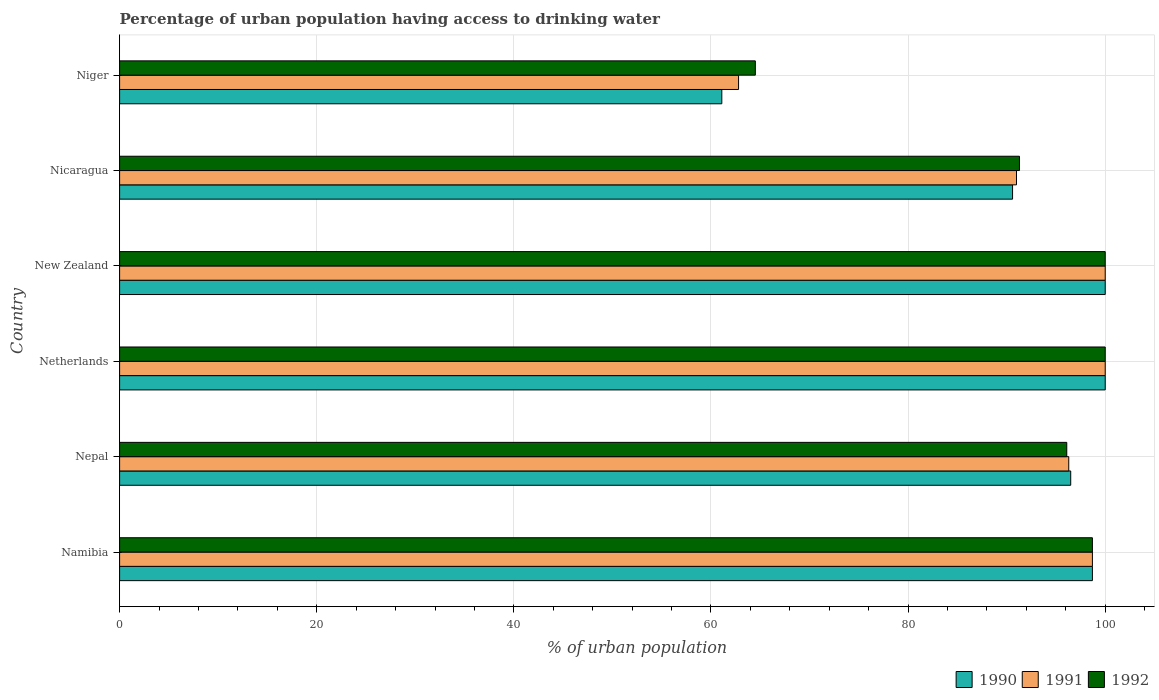How many different coloured bars are there?
Offer a very short reply. 3. Are the number of bars on each tick of the Y-axis equal?
Offer a terse response. Yes. What is the label of the 3rd group of bars from the top?
Give a very brief answer. New Zealand. What is the percentage of urban population having access to drinking water in 1990 in Nepal?
Provide a short and direct response. 96.5. Across all countries, what is the maximum percentage of urban population having access to drinking water in 1991?
Keep it short and to the point. 100. Across all countries, what is the minimum percentage of urban population having access to drinking water in 1991?
Provide a succinct answer. 62.8. In which country was the percentage of urban population having access to drinking water in 1992 maximum?
Make the answer very short. Netherlands. In which country was the percentage of urban population having access to drinking water in 1990 minimum?
Make the answer very short. Niger. What is the total percentage of urban population having access to drinking water in 1991 in the graph?
Give a very brief answer. 548.8. What is the difference between the percentage of urban population having access to drinking water in 1992 in Netherlands and that in Niger?
Your answer should be compact. 35.5. What is the difference between the percentage of urban population having access to drinking water in 1992 in Namibia and the percentage of urban population having access to drinking water in 1990 in Niger?
Keep it short and to the point. 37.6. What is the average percentage of urban population having access to drinking water in 1992 per country?
Give a very brief answer. 91.77. In how many countries, is the percentage of urban population having access to drinking water in 1992 greater than 44 %?
Give a very brief answer. 6. What is the ratio of the percentage of urban population having access to drinking water in 1992 in New Zealand to that in Niger?
Make the answer very short. 1.55. Is the percentage of urban population having access to drinking water in 1990 in Namibia less than that in Niger?
Keep it short and to the point. No. What is the difference between the highest and the second highest percentage of urban population having access to drinking water in 1992?
Provide a succinct answer. 0. What is the difference between the highest and the lowest percentage of urban population having access to drinking water in 1992?
Keep it short and to the point. 35.5. Are all the bars in the graph horizontal?
Your response must be concise. Yes. Are the values on the major ticks of X-axis written in scientific E-notation?
Provide a succinct answer. No. Does the graph contain grids?
Give a very brief answer. Yes. Where does the legend appear in the graph?
Give a very brief answer. Bottom right. How are the legend labels stacked?
Your answer should be very brief. Horizontal. What is the title of the graph?
Your response must be concise. Percentage of urban population having access to drinking water. What is the label or title of the X-axis?
Give a very brief answer. % of urban population. What is the % of urban population of 1990 in Namibia?
Make the answer very short. 98.7. What is the % of urban population in 1991 in Namibia?
Ensure brevity in your answer.  98.7. What is the % of urban population in 1992 in Namibia?
Provide a short and direct response. 98.7. What is the % of urban population of 1990 in Nepal?
Keep it short and to the point. 96.5. What is the % of urban population in 1991 in Nepal?
Your answer should be very brief. 96.3. What is the % of urban population in 1992 in Nepal?
Keep it short and to the point. 96.1. What is the % of urban population in 1991 in Netherlands?
Make the answer very short. 100. What is the % of urban population of 1992 in Netherlands?
Provide a short and direct response. 100. What is the % of urban population of 1990 in New Zealand?
Your answer should be very brief. 100. What is the % of urban population of 1991 in New Zealand?
Offer a terse response. 100. What is the % of urban population of 1990 in Nicaragua?
Provide a short and direct response. 90.6. What is the % of urban population of 1991 in Nicaragua?
Offer a terse response. 91. What is the % of urban population of 1992 in Nicaragua?
Your answer should be compact. 91.3. What is the % of urban population of 1990 in Niger?
Your answer should be very brief. 61.1. What is the % of urban population in 1991 in Niger?
Provide a short and direct response. 62.8. What is the % of urban population in 1992 in Niger?
Ensure brevity in your answer.  64.5. Across all countries, what is the maximum % of urban population in 1990?
Your answer should be very brief. 100. Across all countries, what is the maximum % of urban population of 1991?
Offer a terse response. 100. Across all countries, what is the maximum % of urban population in 1992?
Make the answer very short. 100. Across all countries, what is the minimum % of urban population of 1990?
Your response must be concise. 61.1. Across all countries, what is the minimum % of urban population of 1991?
Provide a succinct answer. 62.8. Across all countries, what is the minimum % of urban population in 1992?
Ensure brevity in your answer.  64.5. What is the total % of urban population of 1990 in the graph?
Keep it short and to the point. 546.9. What is the total % of urban population in 1991 in the graph?
Provide a short and direct response. 548.8. What is the total % of urban population of 1992 in the graph?
Provide a short and direct response. 550.6. What is the difference between the % of urban population of 1992 in Namibia and that in Nepal?
Provide a succinct answer. 2.6. What is the difference between the % of urban population of 1992 in Namibia and that in Netherlands?
Your response must be concise. -1.3. What is the difference between the % of urban population in 1991 in Namibia and that in New Zealand?
Make the answer very short. -1.3. What is the difference between the % of urban population of 1990 in Namibia and that in Niger?
Ensure brevity in your answer.  37.6. What is the difference between the % of urban population in 1991 in Namibia and that in Niger?
Your answer should be very brief. 35.9. What is the difference between the % of urban population in 1992 in Namibia and that in Niger?
Provide a short and direct response. 34.2. What is the difference between the % of urban population of 1992 in Nepal and that in Netherlands?
Make the answer very short. -3.9. What is the difference between the % of urban population in 1991 in Nepal and that in New Zealand?
Provide a succinct answer. -3.7. What is the difference between the % of urban population of 1991 in Nepal and that in Nicaragua?
Offer a terse response. 5.3. What is the difference between the % of urban population in 1990 in Nepal and that in Niger?
Your response must be concise. 35.4. What is the difference between the % of urban population of 1991 in Nepal and that in Niger?
Ensure brevity in your answer.  33.5. What is the difference between the % of urban population of 1992 in Nepal and that in Niger?
Your response must be concise. 31.6. What is the difference between the % of urban population of 1991 in Netherlands and that in New Zealand?
Offer a very short reply. 0. What is the difference between the % of urban population in 1990 in Netherlands and that in Nicaragua?
Provide a short and direct response. 9.4. What is the difference between the % of urban population in 1990 in Netherlands and that in Niger?
Offer a terse response. 38.9. What is the difference between the % of urban population of 1991 in Netherlands and that in Niger?
Make the answer very short. 37.2. What is the difference between the % of urban population in 1992 in Netherlands and that in Niger?
Offer a terse response. 35.5. What is the difference between the % of urban population of 1990 in New Zealand and that in Niger?
Ensure brevity in your answer.  38.9. What is the difference between the % of urban population of 1991 in New Zealand and that in Niger?
Your response must be concise. 37.2. What is the difference between the % of urban population of 1992 in New Zealand and that in Niger?
Ensure brevity in your answer.  35.5. What is the difference between the % of urban population in 1990 in Nicaragua and that in Niger?
Make the answer very short. 29.5. What is the difference between the % of urban population in 1991 in Nicaragua and that in Niger?
Provide a succinct answer. 28.2. What is the difference between the % of urban population of 1992 in Nicaragua and that in Niger?
Your answer should be compact. 26.8. What is the difference between the % of urban population of 1990 in Namibia and the % of urban population of 1992 in Nepal?
Provide a succinct answer. 2.6. What is the difference between the % of urban population of 1991 in Namibia and the % of urban population of 1992 in Netherlands?
Your answer should be compact. -1.3. What is the difference between the % of urban population of 1990 in Namibia and the % of urban population of 1991 in New Zealand?
Make the answer very short. -1.3. What is the difference between the % of urban population of 1990 in Namibia and the % of urban population of 1992 in New Zealand?
Offer a very short reply. -1.3. What is the difference between the % of urban population of 1991 in Namibia and the % of urban population of 1992 in New Zealand?
Offer a very short reply. -1.3. What is the difference between the % of urban population in 1991 in Namibia and the % of urban population in 1992 in Nicaragua?
Offer a very short reply. 7.4. What is the difference between the % of urban population of 1990 in Namibia and the % of urban population of 1991 in Niger?
Your response must be concise. 35.9. What is the difference between the % of urban population in 1990 in Namibia and the % of urban population in 1992 in Niger?
Your response must be concise. 34.2. What is the difference between the % of urban population of 1991 in Namibia and the % of urban population of 1992 in Niger?
Provide a succinct answer. 34.2. What is the difference between the % of urban population of 1990 in Nepal and the % of urban population of 1991 in Netherlands?
Provide a short and direct response. -3.5. What is the difference between the % of urban population in 1990 in Nepal and the % of urban population in 1992 in Netherlands?
Your response must be concise. -3.5. What is the difference between the % of urban population of 1991 in Nepal and the % of urban population of 1992 in Netherlands?
Provide a short and direct response. -3.7. What is the difference between the % of urban population of 1991 in Nepal and the % of urban population of 1992 in New Zealand?
Keep it short and to the point. -3.7. What is the difference between the % of urban population of 1990 in Nepal and the % of urban population of 1991 in Nicaragua?
Give a very brief answer. 5.5. What is the difference between the % of urban population of 1991 in Nepal and the % of urban population of 1992 in Nicaragua?
Offer a terse response. 5. What is the difference between the % of urban population in 1990 in Nepal and the % of urban population in 1991 in Niger?
Offer a terse response. 33.7. What is the difference between the % of urban population of 1990 in Nepal and the % of urban population of 1992 in Niger?
Make the answer very short. 32. What is the difference between the % of urban population in 1991 in Nepal and the % of urban population in 1992 in Niger?
Ensure brevity in your answer.  31.8. What is the difference between the % of urban population in 1991 in Netherlands and the % of urban population in 1992 in New Zealand?
Ensure brevity in your answer.  0. What is the difference between the % of urban population in 1991 in Netherlands and the % of urban population in 1992 in Nicaragua?
Your answer should be very brief. 8.7. What is the difference between the % of urban population in 1990 in Netherlands and the % of urban population in 1991 in Niger?
Your answer should be compact. 37.2. What is the difference between the % of urban population in 1990 in Netherlands and the % of urban population in 1992 in Niger?
Keep it short and to the point. 35.5. What is the difference between the % of urban population of 1991 in Netherlands and the % of urban population of 1992 in Niger?
Provide a short and direct response. 35.5. What is the difference between the % of urban population in 1990 in New Zealand and the % of urban population in 1991 in Niger?
Offer a terse response. 37.2. What is the difference between the % of urban population of 1990 in New Zealand and the % of urban population of 1992 in Niger?
Your response must be concise. 35.5. What is the difference between the % of urban population in 1991 in New Zealand and the % of urban population in 1992 in Niger?
Your answer should be very brief. 35.5. What is the difference between the % of urban population of 1990 in Nicaragua and the % of urban population of 1991 in Niger?
Keep it short and to the point. 27.8. What is the difference between the % of urban population in 1990 in Nicaragua and the % of urban population in 1992 in Niger?
Provide a short and direct response. 26.1. What is the average % of urban population in 1990 per country?
Offer a very short reply. 91.15. What is the average % of urban population in 1991 per country?
Offer a terse response. 91.47. What is the average % of urban population of 1992 per country?
Your answer should be very brief. 91.77. What is the difference between the % of urban population in 1990 and % of urban population in 1992 in Namibia?
Keep it short and to the point. 0. What is the difference between the % of urban population in 1990 and % of urban population in 1991 in Nepal?
Ensure brevity in your answer.  0.2. What is the difference between the % of urban population of 1990 and % of urban population of 1991 in Netherlands?
Your answer should be compact. 0. What is the difference between the % of urban population in 1991 and % of urban population in 1992 in Netherlands?
Offer a very short reply. 0. What is the difference between the % of urban population in 1990 and % of urban population in 1991 in New Zealand?
Your response must be concise. 0. What is the difference between the % of urban population in 1990 and % of urban population in 1992 in New Zealand?
Offer a terse response. 0. What is the difference between the % of urban population of 1990 and % of urban population of 1991 in Nicaragua?
Your response must be concise. -0.4. What is the ratio of the % of urban population of 1990 in Namibia to that in Nepal?
Provide a short and direct response. 1.02. What is the ratio of the % of urban population in 1991 in Namibia to that in Nepal?
Make the answer very short. 1.02. What is the ratio of the % of urban population in 1992 in Namibia to that in Nepal?
Ensure brevity in your answer.  1.03. What is the ratio of the % of urban population in 1990 in Namibia to that in New Zealand?
Keep it short and to the point. 0.99. What is the ratio of the % of urban population in 1991 in Namibia to that in New Zealand?
Offer a very short reply. 0.99. What is the ratio of the % of urban population of 1992 in Namibia to that in New Zealand?
Give a very brief answer. 0.99. What is the ratio of the % of urban population in 1990 in Namibia to that in Nicaragua?
Your answer should be very brief. 1.09. What is the ratio of the % of urban population in 1991 in Namibia to that in Nicaragua?
Keep it short and to the point. 1.08. What is the ratio of the % of urban population of 1992 in Namibia to that in Nicaragua?
Ensure brevity in your answer.  1.08. What is the ratio of the % of urban population in 1990 in Namibia to that in Niger?
Provide a succinct answer. 1.62. What is the ratio of the % of urban population of 1991 in Namibia to that in Niger?
Keep it short and to the point. 1.57. What is the ratio of the % of urban population of 1992 in Namibia to that in Niger?
Offer a very short reply. 1.53. What is the ratio of the % of urban population of 1991 in Nepal to that in Netherlands?
Make the answer very short. 0.96. What is the ratio of the % of urban population in 1992 in Nepal to that in Netherlands?
Your answer should be very brief. 0.96. What is the ratio of the % of urban population in 1991 in Nepal to that in New Zealand?
Give a very brief answer. 0.96. What is the ratio of the % of urban population of 1992 in Nepal to that in New Zealand?
Your answer should be very brief. 0.96. What is the ratio of the % of urban population in 1990 in Nepal to that in Nicaragua?
Make the answer very short. 1.07. What is the ratio of the % of urban population in 1991 in Nepal to that in Nicaragua?
Keep it short and to the point. 1.06. What is the ratio of the % of urban population in 1992 in Nepal to that in Nicaragua?
Offer a very short reply. 1.05. What is the ratio of the % of urban population of 1990 in Nepal to that in Niger?
Offer a terse response. 1.58. What is the ratio of the % of urban population of 1991 in Nepal to that in Niger?
Provide a short and direct response. 1.53. What is the ratio of the % of urban population in 1992 in Nepal to that in Niger?
Give a very brief answer. 1.49. What is the ratio of the % of urban population in 1990 in Netherlands to that in Nicaragua?
Provide a short and direct response. 1.1. What is the ratio of the % of urban population of 1991 in Netherlands to that in Nicaragua?
Provide a short and direct response. 1.1. What is the ratio of the % of urban population of 1992 in Netherlands to that in Nicaragua?
Your answer should be compact. 1.1. What is the ratio of the % of urban population in 1990 in Netherlands to that in Niger?
Give a very brief answer. 1.64. What is the ratio of the % of urban population of 1991 in Netherlands to that in Niger?
Your response must be concise. 1.59. What is the ratio of the % of urban population of 1992 in Netherlands to that in Niger?
Ensure brevity in your answer.  1.55. What is the ratio of the % of urban population in 1990 in New Zealand to that in Nicaragua?
Provide a short and direct response. 1.1. What is the ratio of the % of urban population of 1991 in New Zealand to that in Nicaragua?
Provide a succinct answer. 1.1. What is the ratio of the % of urban population in 1992 in New Zealand to that in Nicaragua?
Provide a short and direct response. 1.1. What is the ratio of the % of urban population of 1990 in New Zealand to that in Niger?
Provide a short and direct response. 1.64. What is the ratio of the % of urban population in 1991 in New Zealand to that in Niger?
Make the answer very short. 1.59. What is the ratio of the % of urban population of 1992 in New Zealand to that in Niger?
Make the answer very short. 1.55. What is the ratio of the % of urban population of 1990 in Nicaragua to that in Niger?
Provide a succinct answer. 1.48. What is the ratio of the % of urban population in 1991 in Nicaragua to that in Niger?
Your answer should be compact. 1.45. What is the ratio of the % of urban population of 1992 in Nicaragua to that in Niger?
Give a very brief answer. 1.42. What is the difference between the highest and the second highest % of urban population of 1990?
Provide a succinct answer. 0. What is the difference between the highest and the second highest % of urban population of 1991?
Offer a terse response. 0. What is the difference between the highest and the lowest % of urban population in 1990?
Your answer should be very brief. 38.9. What is the difference between the highest and the lowest % of urban population of 1991?
Provide a succinct answer. 37.2. What is the difference between the highest and the lowest % of urban population in 1992?
Keep it short and to the point. 35.5. 